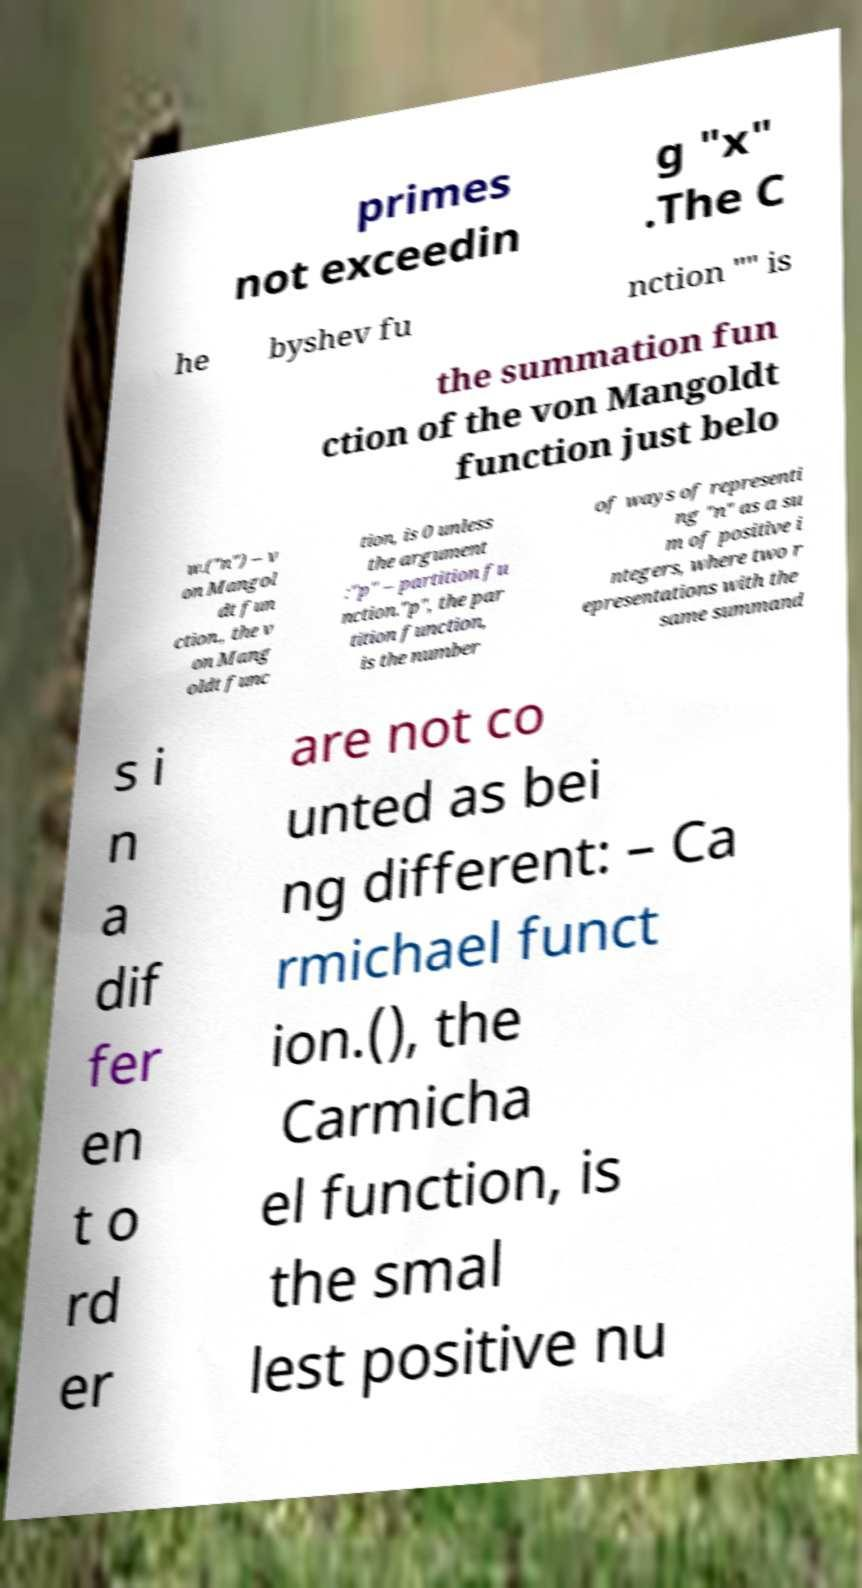I need the written content from this picture converted into text. Can you do that? primes not exceedin g "x" .The C he byshev fu nction "" is the summation fun ction of the von Mangoldt function just belo w.("n") – v on Mangol dt fun ction., the v on Mang oldt func tion, is 0 unless the argument :"p" – partition fu nction."p", the par tition function, is the number of ways of representi ng "n" as a su m of positive i ntegers, where two r epresentations with the same summand s i n a dif fer en t o rd er are not co unted as bei ng different: – Ca rmichael funct ion.(), the Carmicha el function, is the smal lest positive nu 